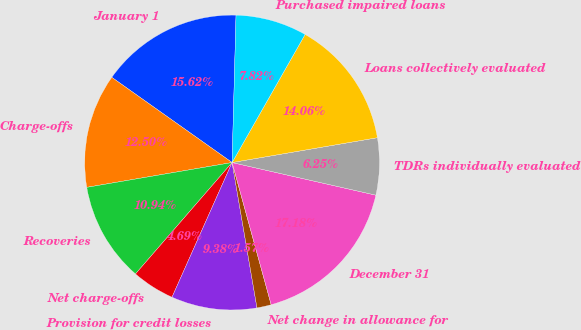Convert chart. <chart><loc_0><loc_0><loc_500><loc_500><pie_chart><fcel>January 1<fcel>Charge-offs<fcel>Recoveries<fcel>Net charge-offs<fcel>Provision for credit losses<fcel>Net change in allowance for<fcel>December 31<fcel>TDRs individually evaluated<fcel>Loans collectively evaluated<fcel>Purchased impaired loans<nl><fcel>15.62%<fcel>12.5%<fcel>10.94%<fcel>4.69%<fcel>9.38%<fcel>1.57%<fcel>17.18%<fcel>6.25%<fcel>14.06%<fcel>7.82%<nl></chart> 